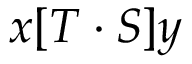<formula> <loc_0><loc_0><loc_500><loc_500>x [ T \cdot S ] y</formula> 